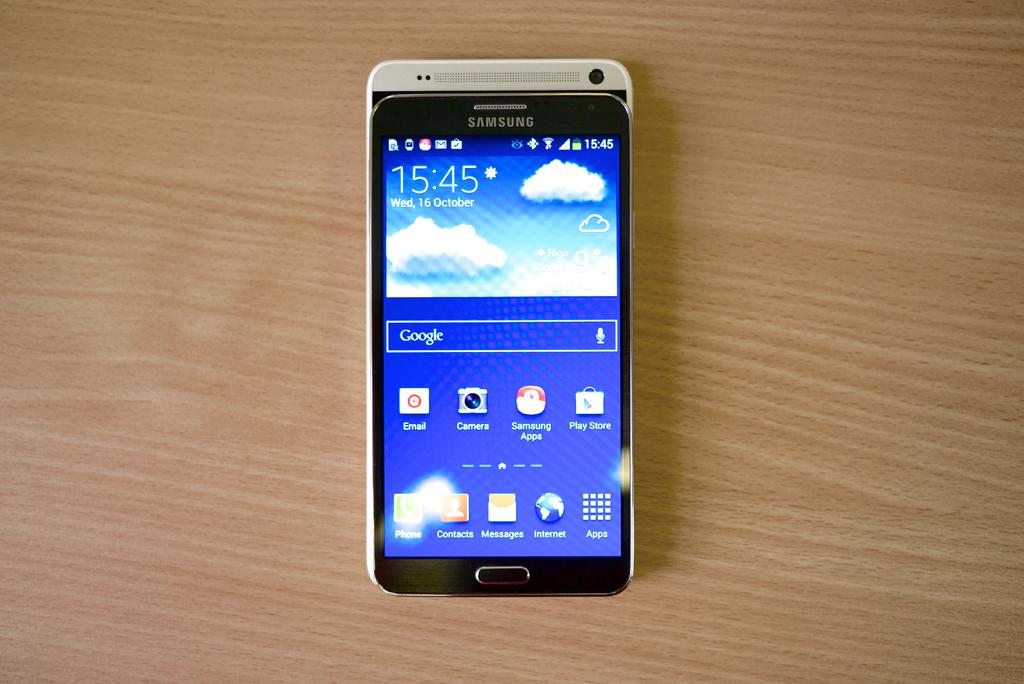Provide a one-sentence caption for the provided image. A cell phone with 15:45 and apps on the display. 